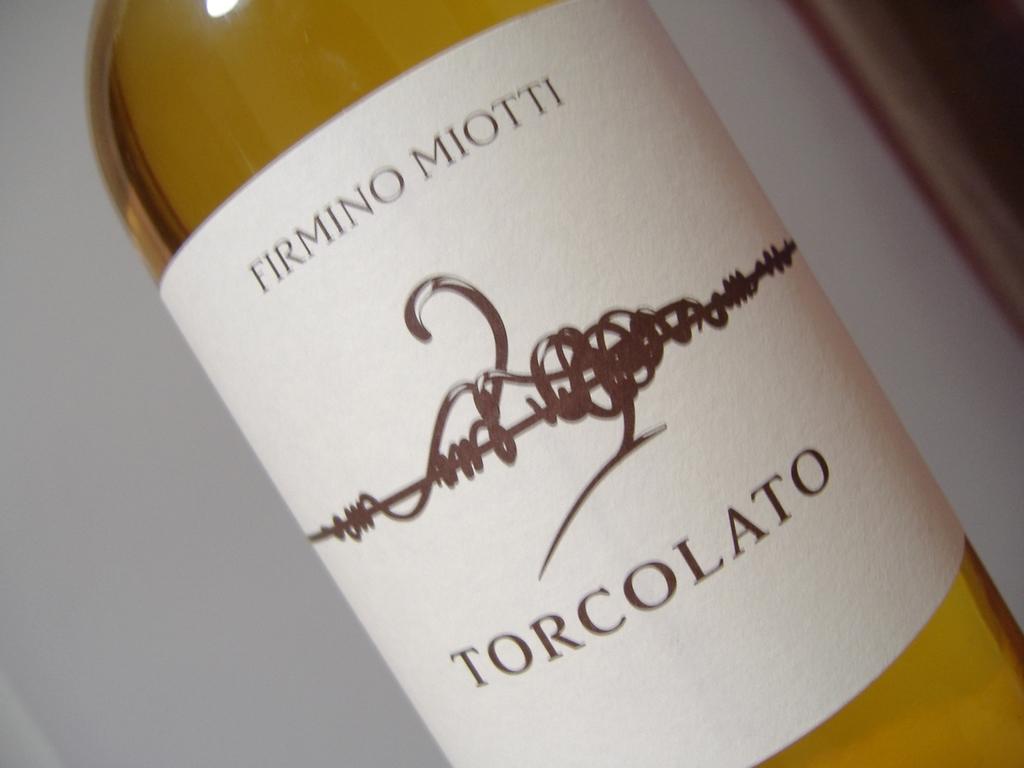What are the first three letters on the bottom word?
Keep it short and to the point. Tor. 